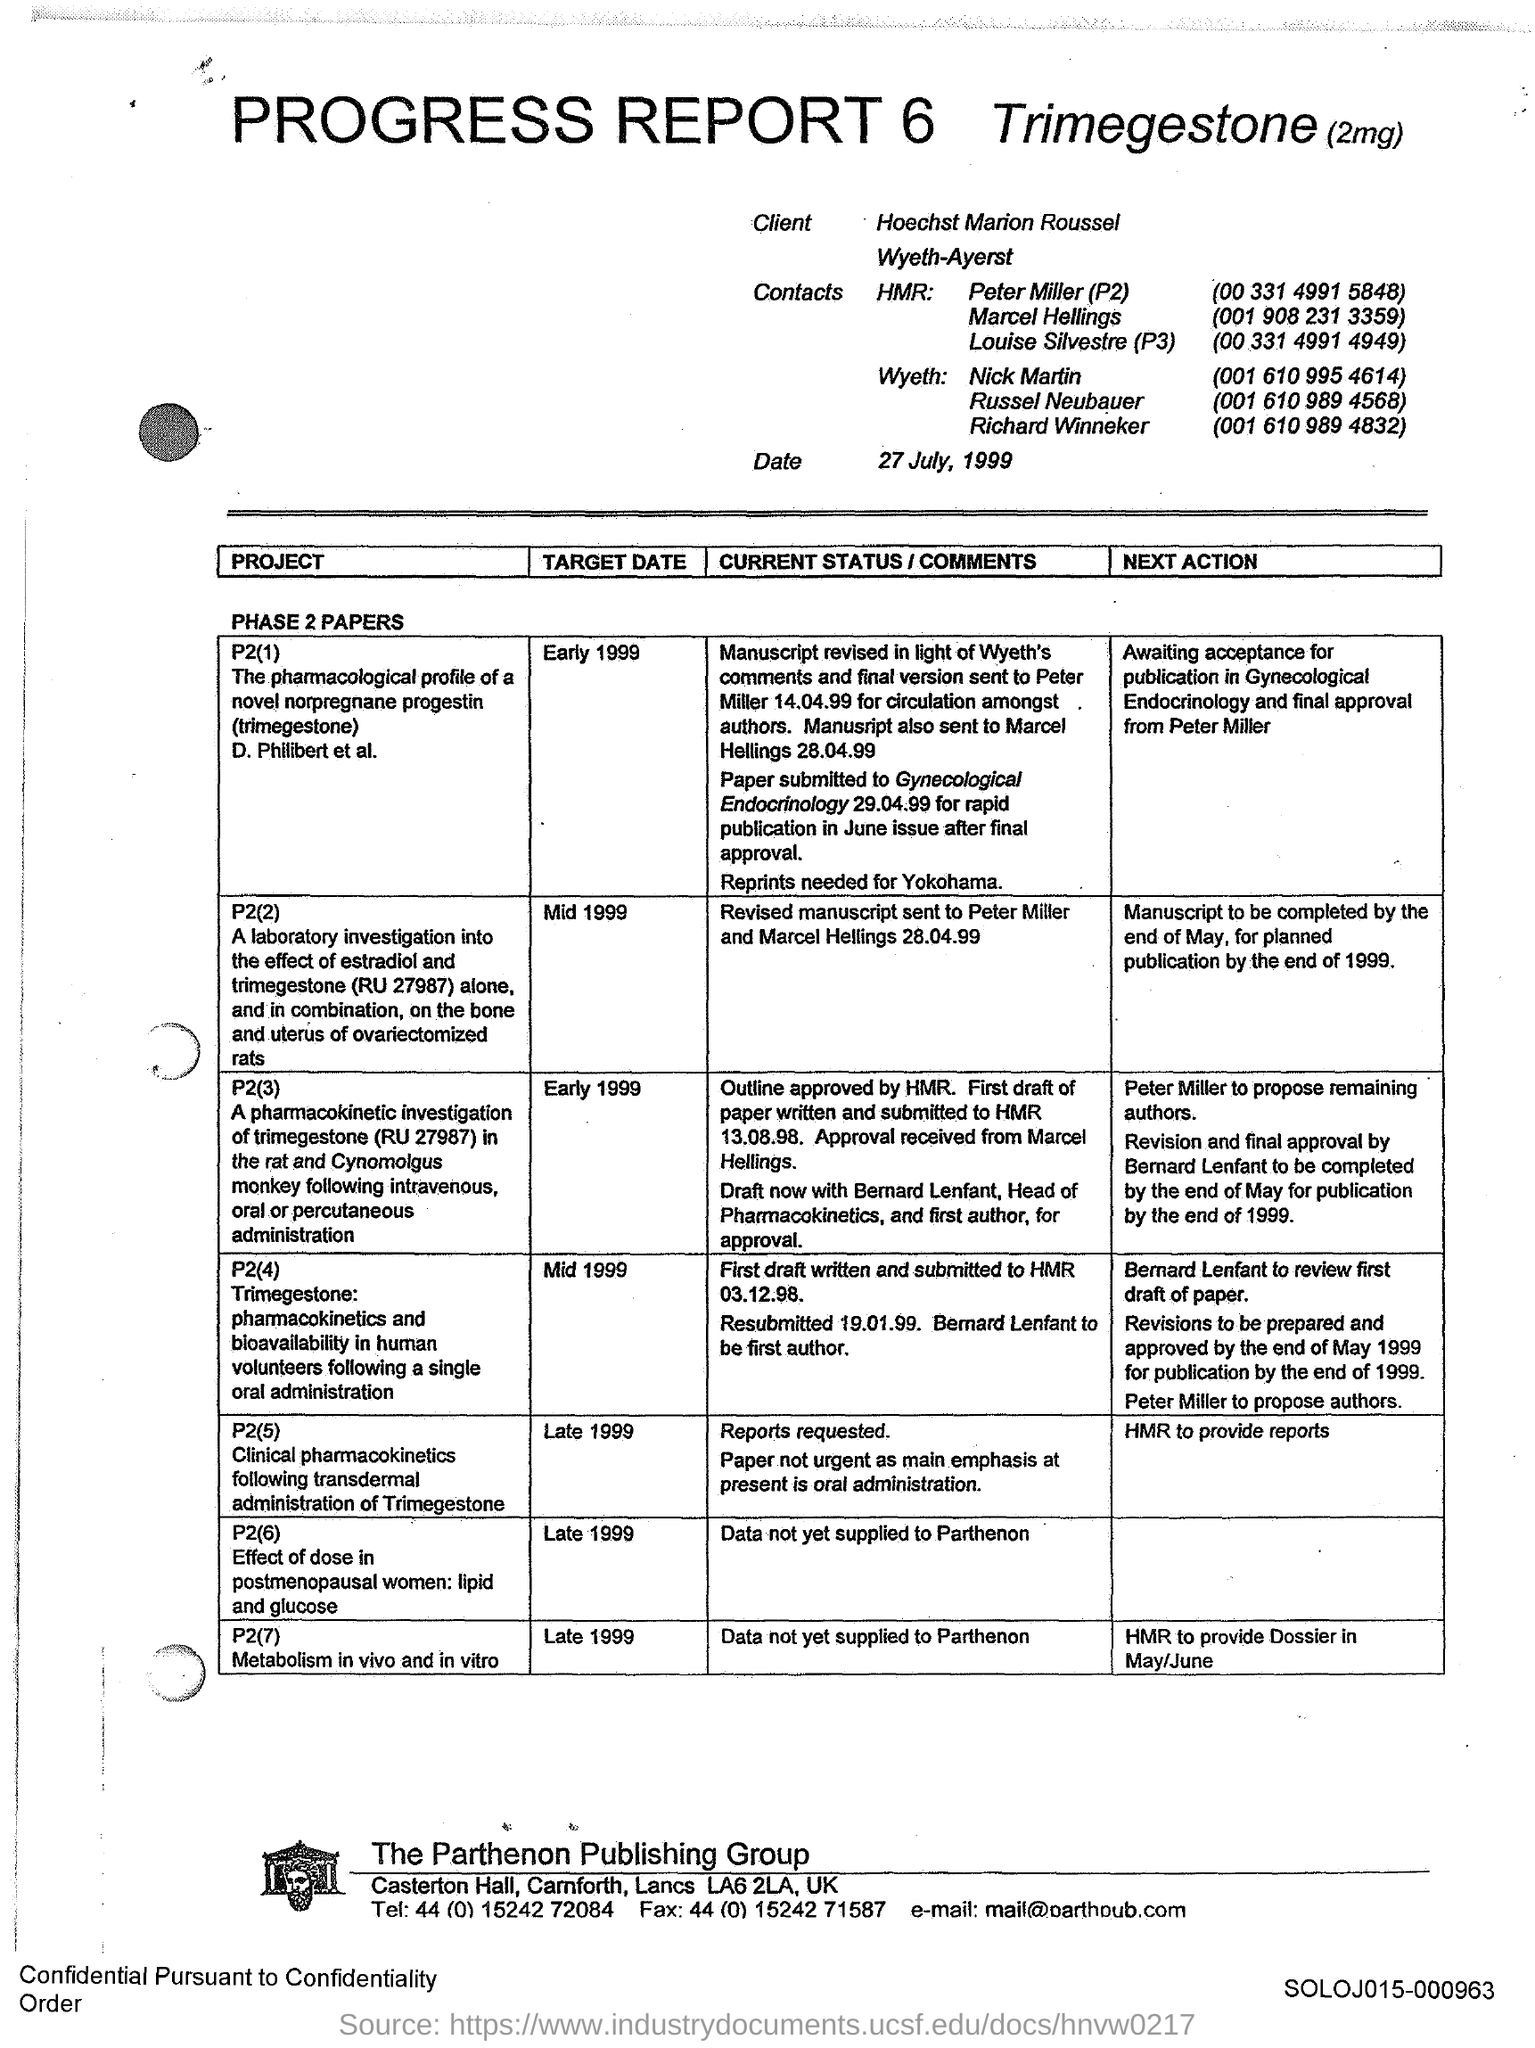Mention a couple of crucial points in this snapshot. This is a progress report, number 6. 